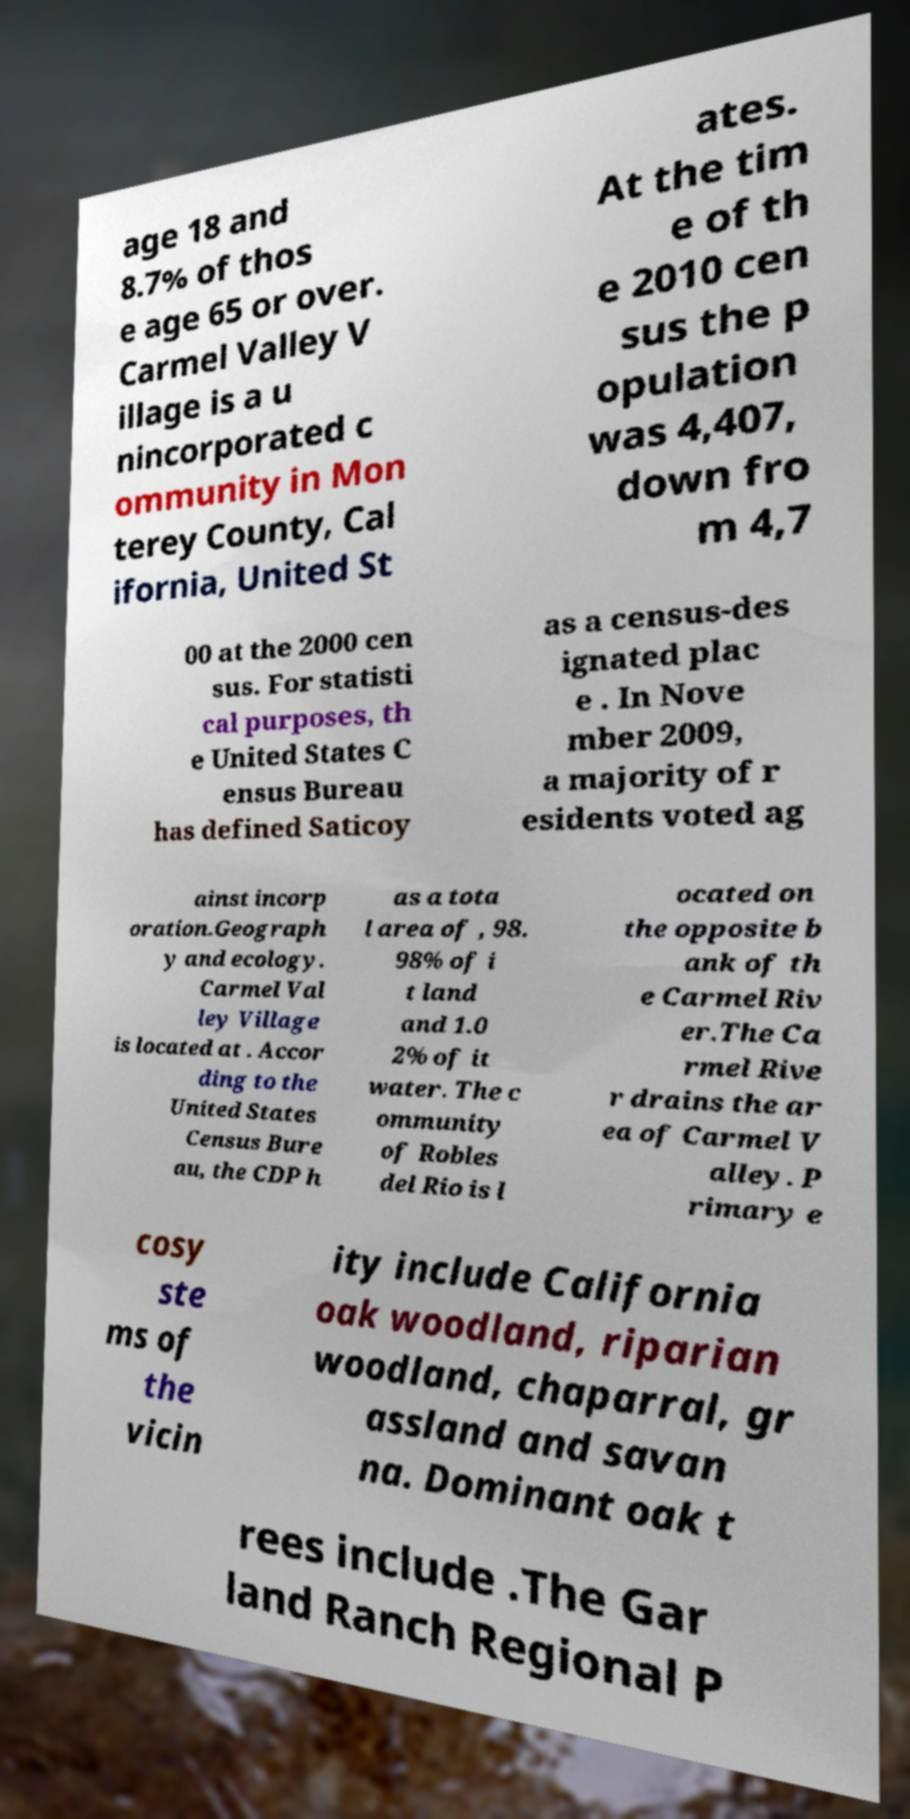Please identify and transcribe the text found in this image. age 18 and 8.7% of thos e age 65 or over. Carmel Valley V illage is a u nincorporated c ommunity in Mon terey County, Cal ifornia, United St ates. At the tim e of th e 2010 cen sus the p opulation was 4,407, down fro m 4,7 00 at the 2000 cen sus. For statisti cal purposes, th e United States C ensus Bureau has defined Saticoy as a census-des ignated plac e . In Nove mber 2009, a majority of r esidents voted ag ainst incorp oration.Geograph y and ecology. Carmel Val ley Village is located at . Accor ding to the United States Census Bure au, the CDP h as a tota l area of , 98. 98% of i t land and 1.0 2% of it water. The c ommunity of Robles del Rio is l ocated on the opposite b ank of th e Carmel Riv er.The Ca rmel Rive r drains the ar ea of Carmel V alley. P rimary e cosy ste ms of the vicin ity include California oak woodland, riparian woodland, chaparral, gr assland and savan na. Dominant oak t rees include .The Gar land Ranch Regional P 